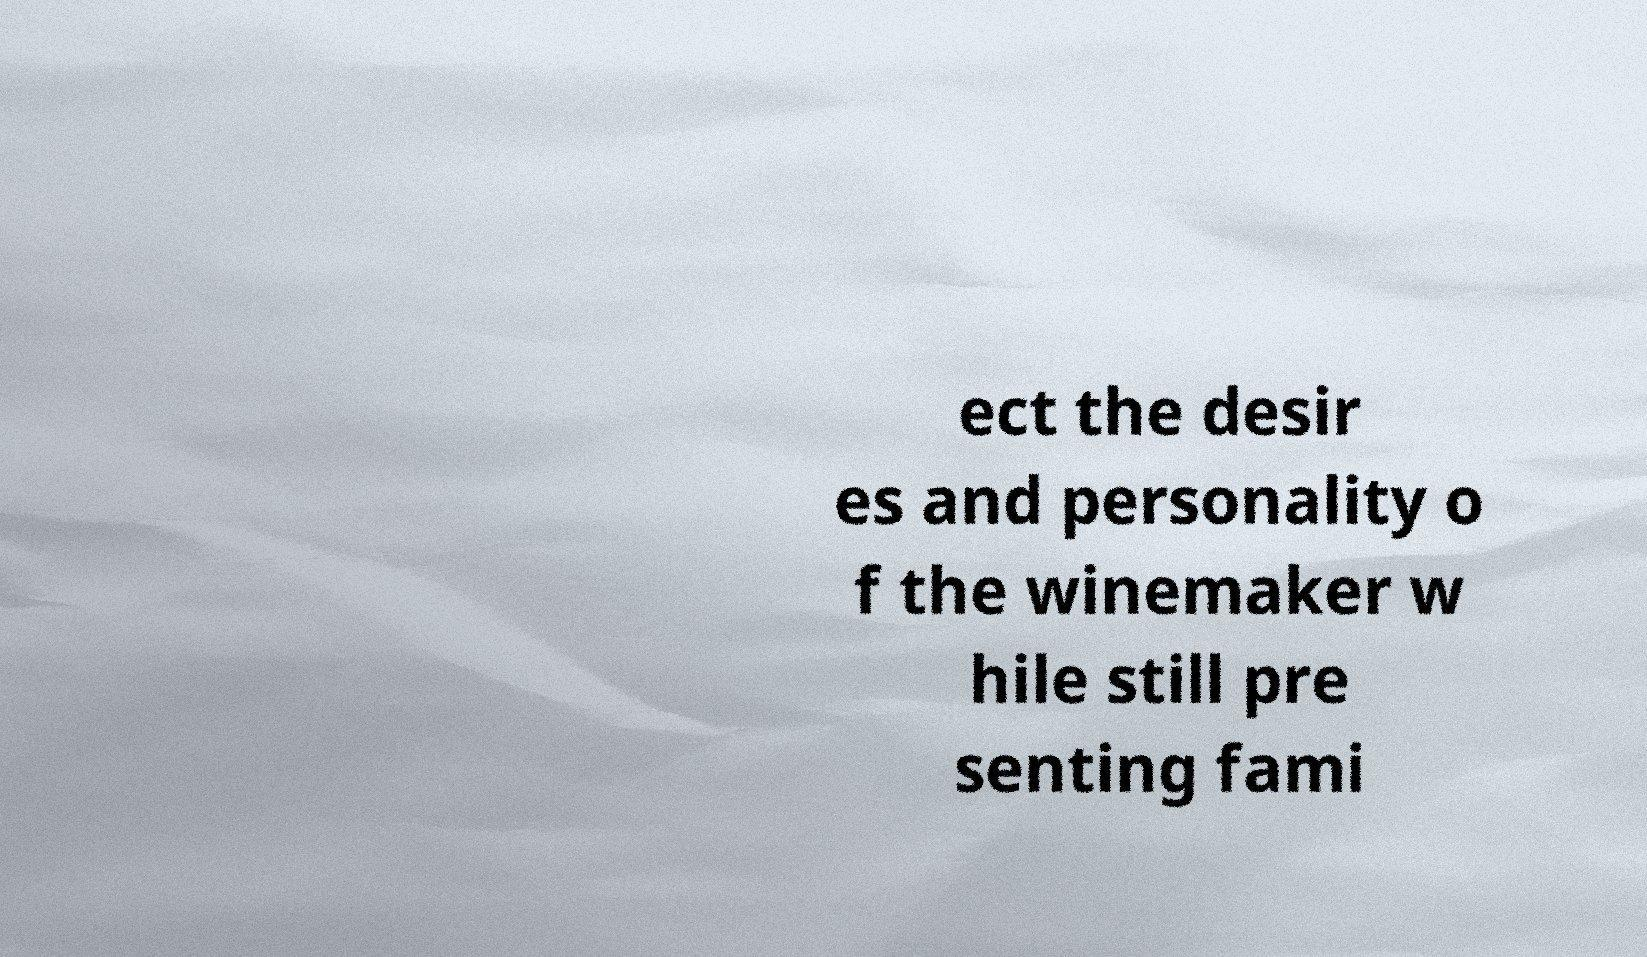Could you assist in decoding the text presented in this image and type it out clearly? ect the desir es and personality o f the winemaker w hile still pre senting fami 